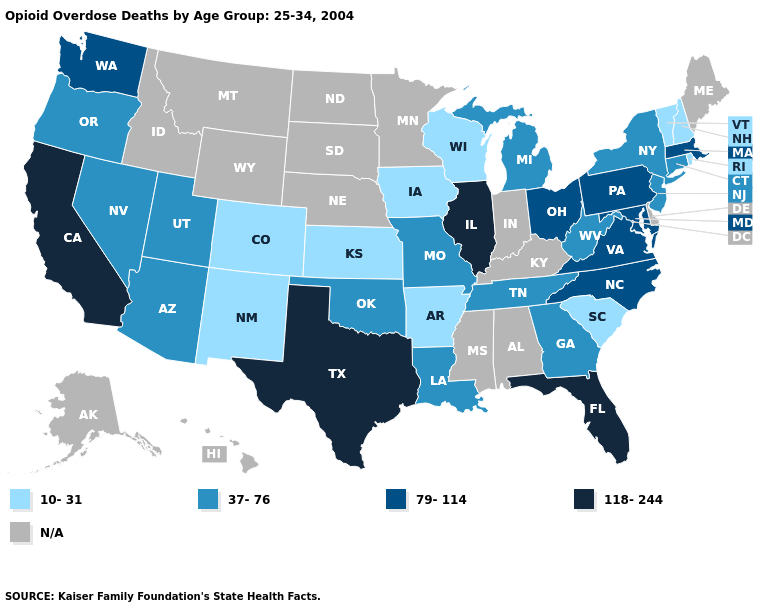Is the legend a continuous bar?
Concise answer only. No. Is the legend a continuous bar?
Keep it brief. No. Is the legend a continuous bar?
Give a very brief answer. No. What is the highest value in the West ?
Quick response, please. 118-244. Which states hav the highest value in the MidWest?
Give a very brief answer. Illinois. What is the value of Oklahoma?
Write a very short answer. 37-76. What is the highest value in the USA?
Short answer required. 118-244. Does Iowa have the highest value in the MidWest?
Answer briefly. No. What is the highest value in the USA?
Write a very short answer. 118-244. What is the value of Alabama?
Short answer required. N/A. Name the states that have a value in the range 10-31?
Write a very short answer. Arkansas, Colorado, Iowa, Kansas, New Hampshire, New Mexico, Rhode Island, South Carolina, Vermont, Wisconsin. Name the states that have a value in the range 79-114?
Answer briefly. Maryland, Massachusetts, North Carolina, Ohio, Pennsylvania, Virginia, Washington. Which states have the lowest value in the USA?
Give a very brief answer. Arkansas, Colorado, Iowa, Kansas, New Hampshire, New Mexico, Rhode Island, South Carolina, Vermont, Wisconsin. What is the value of Florida?
Be succinct. 118-244. 